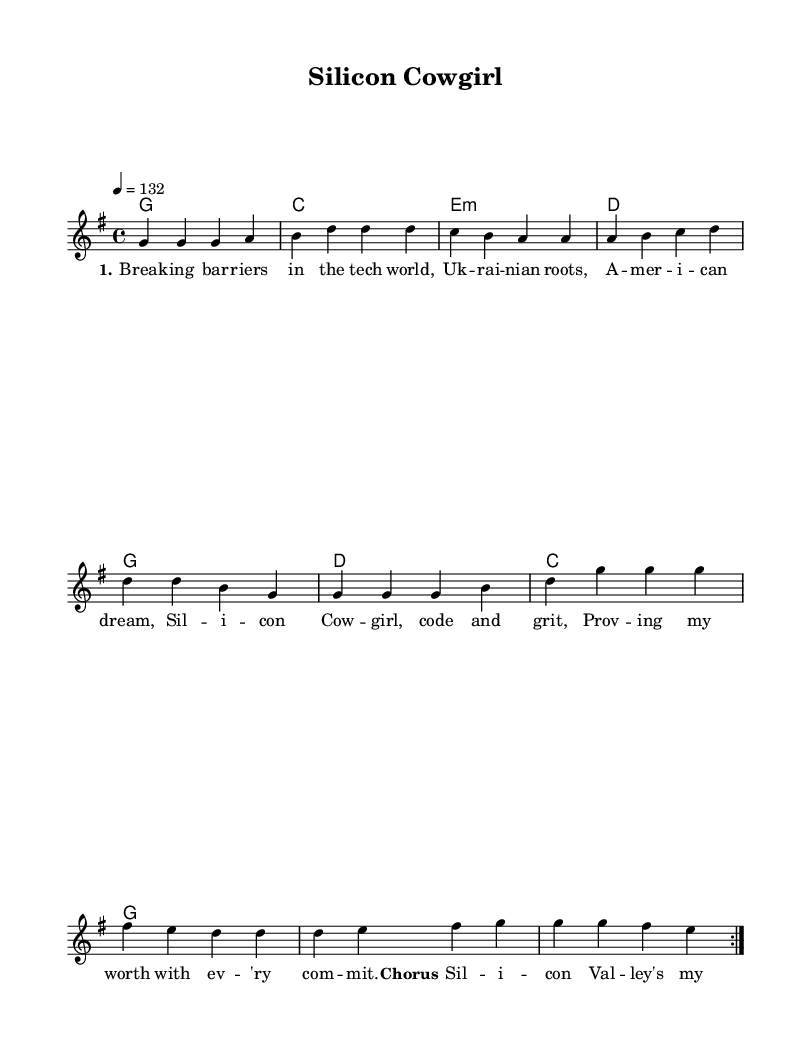What is the key signature of this music? The key signature is G major, which has one sharp (F#).
Answer: G major What is the time signature of the piece? The time signature is 4/4, which means there are four beats in each measure.
Answer: 4/4 What is the tempo marking for this piece? The tempo marking is 132 beats per minute, indicating a moderately fast pace.
Answer: 132 How many times does the verse repeat? The verse repeats twice as indicated by the "repeat volta" marking.
Answer: Two What is the title of the song? The title "Silicon Cowgirl" is shown at the top of the sheet music in the header section.
Answer: Silicon Cowgirl What are the lyrics in the chorus expressing? The lyrics in the chorus express themes of bravery and taking on challenges in Silicon Valley, emphasizing confidence in overcoming fears.
Answer: Bravery and confidence Which chord is used in the last measure of the chorus? The last measure of the chorus uses the G major chord, which is indicated by the chord symbols.
Answer: G major 